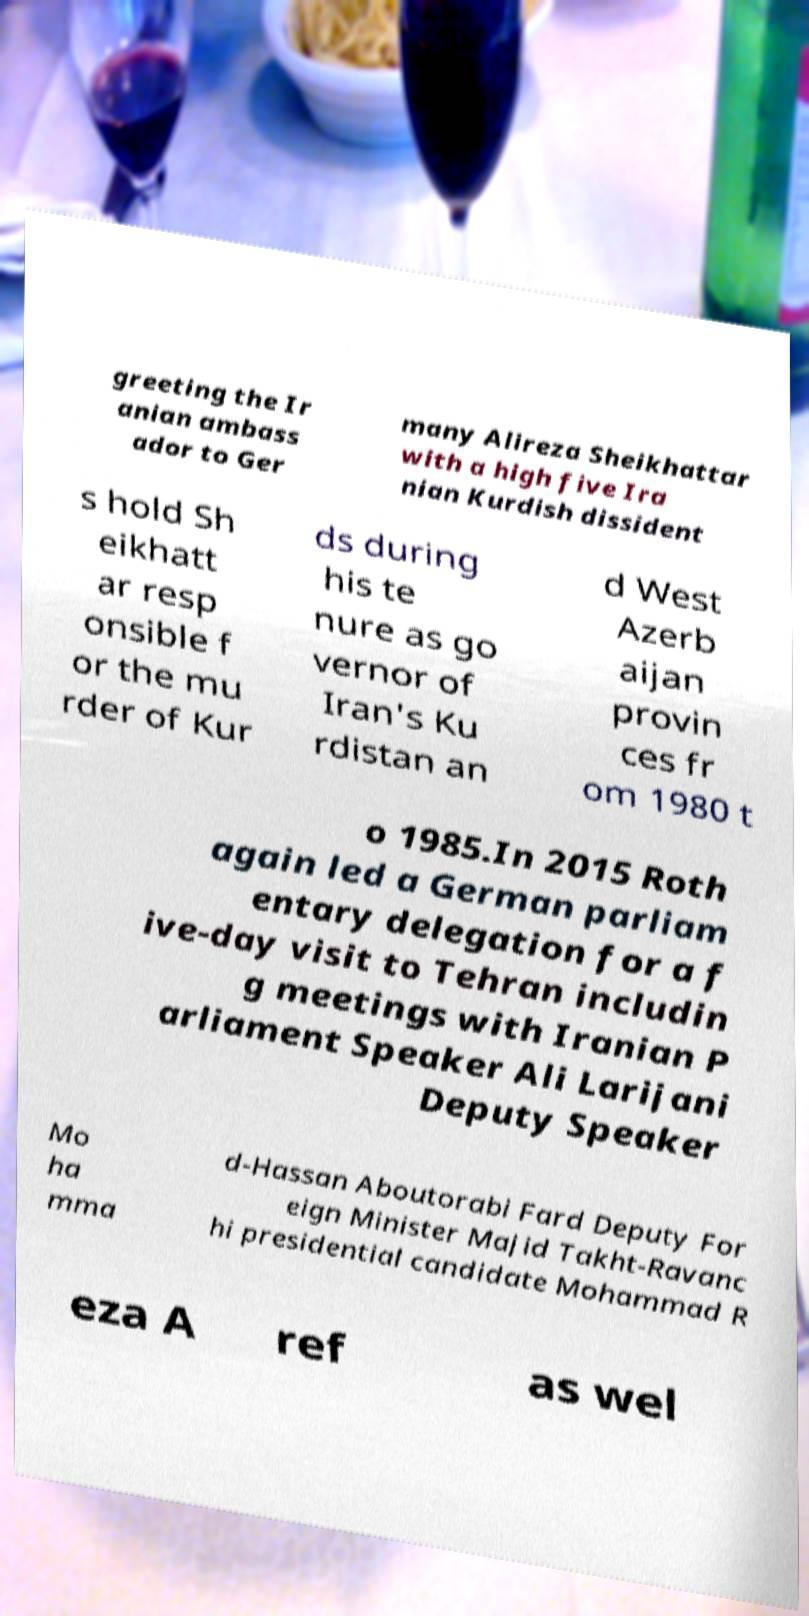Could you extract and type out the text from this image? greeting the Ir anian ambass ador to Ger many Alireza Sheikhattar with a high five Ira nian Kurdish dissident s hold Sh eikhatt ar resp onsible f or the mu rder of Kur ds during his te nure as go vernor of Iran's Ku rdistan an d West Azerb aijan provin ces fr om 1980 t o 1985.In 2015 Roth again led a German parliam entary delegation for a f ive-day visit to Tehran includin g meetings with Iranian P arliament Speaker Ali Larijani Deputy Speaker Mo ha mma d-Hassan Aboutorabi Fard Deputy For eign Minister Majid Takht-Ravanc hi presidential candidate Mohammad R eza A ref as wel 